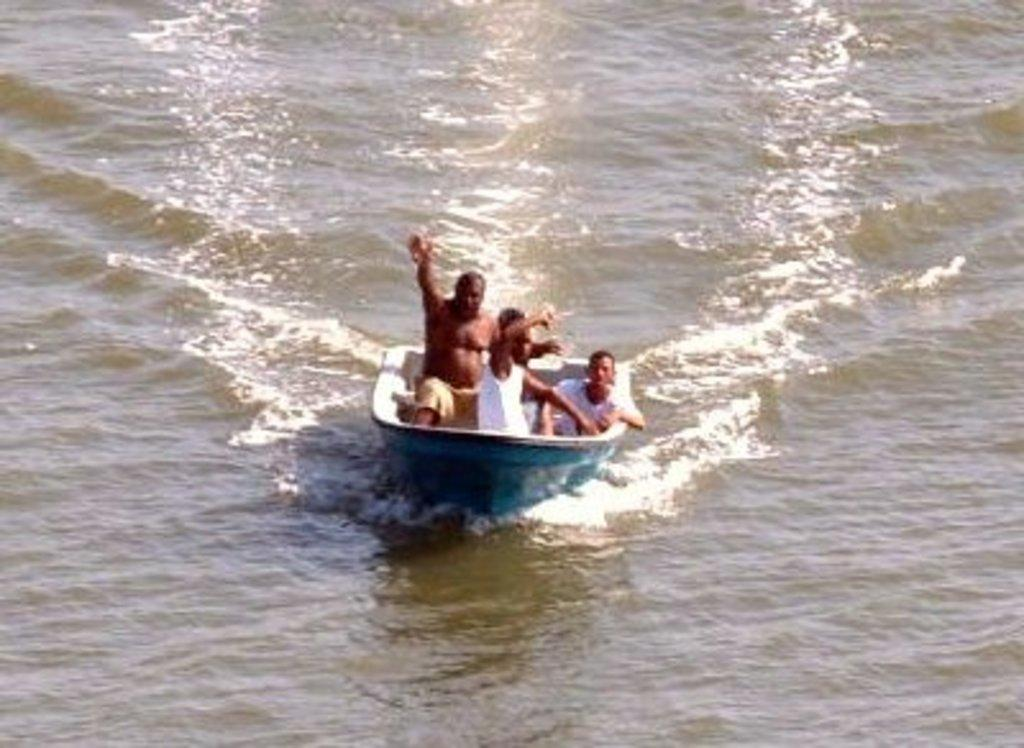What is the main subject of the image? The main subject of the image is a boat. Where is the boat located? The boat is on water. How many people are riding the boat? There are three persons riding the boat. What type of animal can be seen swimming alongside the boat in the image? There is no animal swimming alongside the boat in the image; it only shows the boat and the three persons riding it. 